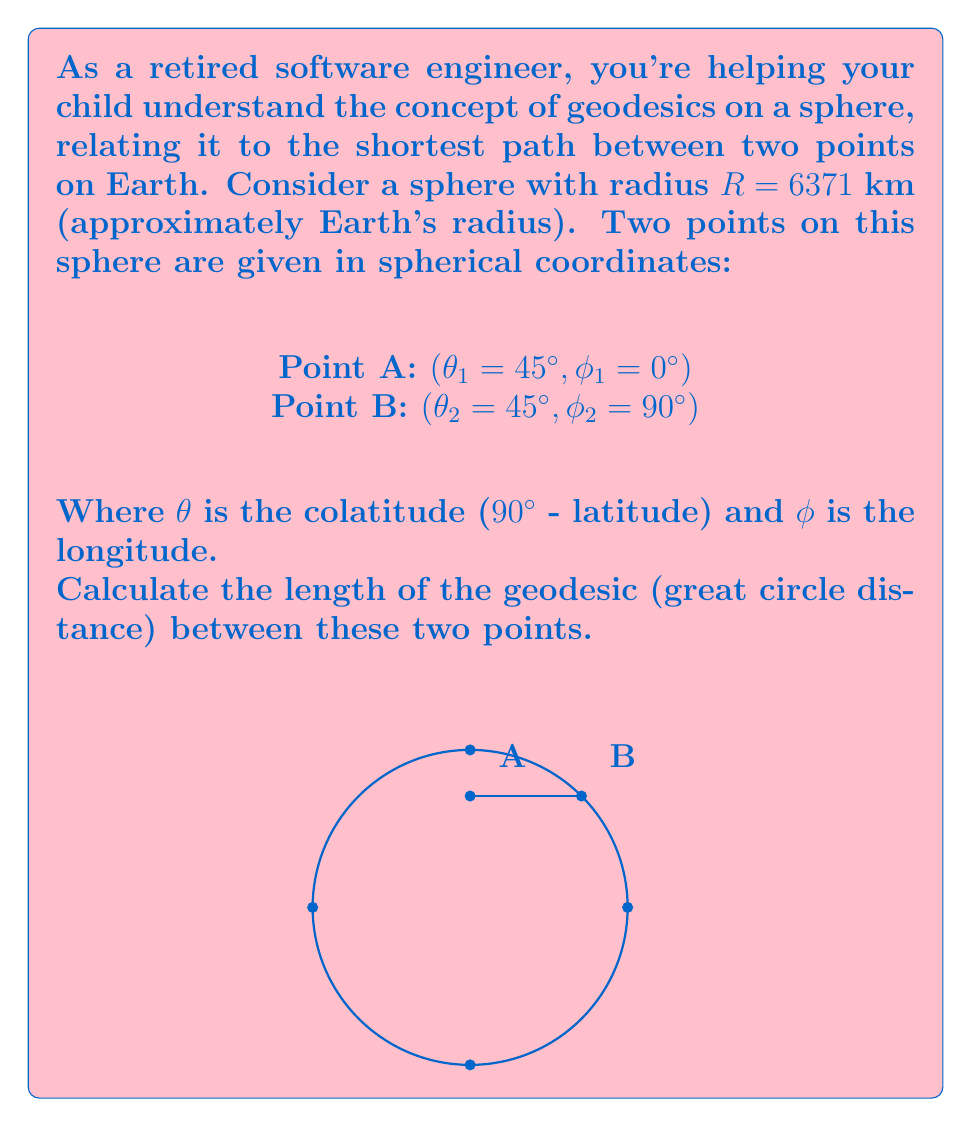Help me with this question. Let's approach this step-by-step:

1) The formula for the great circle distance $d$ between two points on a sphere is given by the spherical law of cosines:

   $$d = R \cdot \arccos(\sin\theta_1 \sin\theta_2 + \cos\theta_1 \cos\theta_2 \cos(\phi_2 - \phi_1))$$

2) We need to convert our angles from degrees to radians:
   $45° = \frac{\pi}{4}$ radians
   $90° = \frac{\pi}{2}$ radians

3) Now, let's substitute our values into the formula:
   $R = 6371$ km
   $\theta_1 = \theta_2 = \frac{\pi}{4}$
   $\phi_1 = 0$
   $\phi_2 = \frac{\pi}{2}$

4) Simplifying the expression inside the arccos:
   $$\sin(\frac{\pi}{4}) \sin(\frac{\pi}{4}) + \cos(\frac{\pi}{4}) \cos(\frac{\pi}{4}) \cos(\frac{\pi}{2} - 0)$$

5) We know that $\sin(\frac{\pi}{4}) = \cos(\frac{\pi}{4}) = \frac{1}{\sqrt{2}}$ and $\cos(\frac{\pi}{2}) = 0$:
   $$(\frac{1}{\sqrt{2}})(\frac{1}{\sqrt{2}}) + (\frac{1}{\sqrt{2}})(\frac{1}{\sqrt{2}})(0) = \frac{1}{2}$$

6) Now our equation looks like:
   $$d = 6371 \cdot \arccos(\frac{1}{2})$$

7) We know that $\arccos(\frac{1}{2}) = \frac{\pi}{3}$

8) Therefore:
   $$d = 6371 \cdot \frac{\pi}{3} \approx 6671.7 \text{ km}$$
Answer: 6671.7 km 